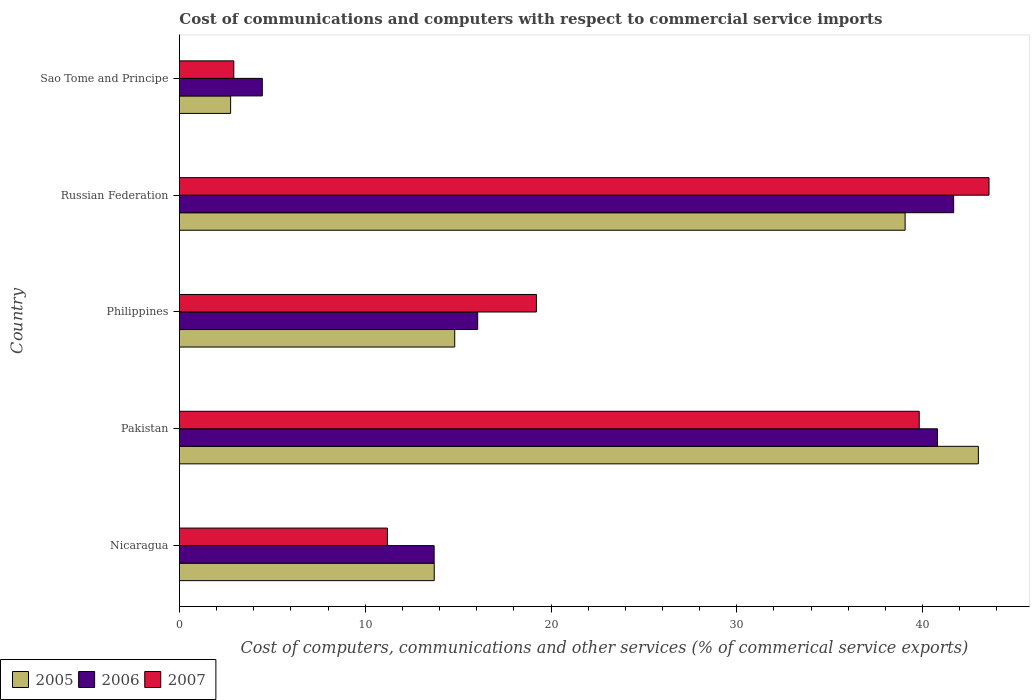How many different coloured bars are there?
Give a very brief answer. 3. Are the number of bars per tick equal to the number of legend labels?
Give a very brief answer. Yes. Are the number of bars on each tick of the Y-axis equal?
Give a very brief answer. Yes. How many bars are there on the 4th tick from the top?
Your response must be concise. 3. How many bars are there on the 5th tick from the bottom?
Offer a very short reply. 3. What is the label of the 4th group of bars from the top?
Ensure brevity in your answer.  Pakistan. What is the cost of communications and computers in 2007 in Philippines?
Provide a succinct answer. 19.22. Across all countries, what is the maximum cost of communications and computers in 2005?
Offer a terse response. 43. Across all countries, what is the minimum cost of communications and computers in 2007?
Offer a very short reply. 2.93. In which country was the cost of communications and computers in 2007 maximum?
Offer a very short reply. Russian Federation. In which country was the cost of communications and computers in 2005 minimum?
Ensure brevity in your answer.  Sao Tome and Principe. What is the total cost of communications and computers in 2005 in the graph?
Provide a succinct answer. 113.35. What is the difference between the cost of communications and computers in 2007 in Nicaragua and that in Philippines?
Provide a succinct answer. -8.02. What is the difference between the cost of communications and computers in 2006 in Russian Federation and the cost of communications and computers in 2005 in Philippines?
Provide a succinct answer. 26.85. What is the average cost of communications and computers in 2005 per country?
Give a very brief answer. 22.67. What is the difference between the cost of communications and computers in 2007 and cost of communications and computers in 2006 in Philippines?
Offer a very short reply. 3.16. In how many countries, is the cost of communications and computers in 2006 greater than 24 %?
Keep it short and to the point. 2. What is the ratio of the cost of communications and computers in 2005 in Pakistan to that in Russian Federation?
Ensure brevity in your answer.  1.1. What is the difference between the highest and the second highest cost of communications and computers in 2006?
Your response must be concise. 0.87. What is the difference between the highest and the lowest cost of communications and computers in 2006?
Your answer should be compact. 37.21. Is the sum of the cost of communications and computers in 2007 in Philippines and Russian Federation greater than the maximum cost of communications and computers in 2005 across all countries?
Your answer should be very brief. Yes. What does the 3rd bar from the top in Philippines represents?
Provide a short and direct response. 2005. How many bars are there?
Provide a succinct answer. 15. Are all the bars in the graph horizontal?
Provide a succinct answer. Yes. What is the difference between two consecutive major ticks on the X-axis?
Give a very brief answer. 10. Does the graph contain any zero values?
Offer a terse response. No. Does the graph contain grids?
Your answer should be compact. No. How many legend labels are there?
Your answer should be very brief. 3. What is the title of the graph?
Keep it short and to the point. Cost of communications and computers with respect to commercial service imports. Does "1964" appear as one of the legend labels in the graph?
Offer a terse response. No. What is the label or title of the X-axis?
Ensure brevity in your answer.  Cost of computers, communications and other services (% of commerical service exports). What is the Cost of computers, communications and other services (% of commerical service exports) in 2005 in Nicaragua?
Offer a terse response. 13.72. What is the Cost of computers, communications and other services (% of commerical service exports) of 2006 in Nicaragua?
Provide a short and direct response. 13.71. What is the Cost of computers, communications and other services (% of commerical service exports) of 2007 in Nicaragua?
Make the answer very short. 11.2. What is the Cost of computers, communications and other services (% of commerical service exports) of 2005 in Pakistan?
Keep it short and to the point. 43. What is the Cost of computers, communications and other services (% of commerical service exports) of 2006 in Pakistan?
Offer a very short reply. 40.8. What is the Cost of computers, communications and other services (% of commerical service exports) in 2007 in Pakistan?
Provide a succinct answer. 39.82. What is the Cost of computers, communications and other services (% of commerical service exports) in 2005 in Philippines?
Give a very brief answer. 14.82. What is the Cost of computers, communications and other services (% of commerical service exports) in 2006 in Philippines?
Provide a short and direct response. 16.05. What is the Cost of computers, communications and other services (% of commerical service exports) in 2007 in Philippines?
Give a very brief answer. 19.22. What is the Cost of computers, communications and other services (% of commerical service exports) of 2005 in Russian Federation?
Your response must be concise. 39.06. What is the Cost of computers, communications and other services (% of commerical service exports) of 2006 in Russian Federation?
Offer a very short reply. 41.67. What is the Cost of computers, communications and other services (% of commerical service exports) in 2007 in Russian Federation?
Give a very brief answer. 43.57. What is the Cost of computers, communications and other services (% of commerical service exports) in 2005 in Sao Tome and Principe?
Offer a very short reply. 2.76. What is the Cost of computers, communications and other services (% of commerical service exports) of 2006 in Sao Tome and Principe?
Offer a terse response. 4.46. What is the Cost of computers, communications and other services (% of commerical service exports) of 2007 in Sao Tome and Principe?
Make the answer very short. 2.93. Across all countries, what is the maximum Cost of computers, communications and other services (% of commerical service exports) of 2005?
Ensure brevity in your answer.  43. Across all countries, what is the maximum Cost of computers, communications and other services (% of commerical service exports) of 2006?
Ensure brevity in your answer.  41.67. Across all countries, what is the maximum Cost of computers, communications and other services (% of commerical service exports) in 2007?
Provide a succinct answer. 43.57. Across all countries, what is the minimum Cost of computers, communications and other services (% of commerical service exports) in 2005?
Your answer should be compact. 2.76. Across all countries, what is the minimum Cost of computers, communications and other services (% of commerical service exports) of 2006?
Your answer should be very brief. 4.46. Across all countries, what is the minimum Cost of computers, communications and other services (% of commerical service exports) of 2007?
Your response must be concise. 2.93. What is the total Cost of computers, communications and other services (% of commerical service exports) of 2005 in the graph?
Your answer should be compact. 113.35. What is the total Cost of computers, communications and other services (% of commerical service exports) of 2006 in the graph?
Provide a short and direct response. 116.7. What is the total Cost of computers, communications and other services (% of commerical service exports) in 2007 in the graph?
Offer a very short reply. 116.73. What is the difference between the Cost of computers, communications and other services (% of commerical service exports) of 2005 in Nicaragua and that in Pakistan?
Ensure brevity in your answer.  -29.29. What is the difference between the Cost of computers, communications and other services (% of commerical service exports) in 2006 in Nicaragua and that in Pakistan?
Ensure brevity in your answer.  -27.09. What is the difference between the Cost of computers, communications and other services (% of commerical service exports) in 2007 in Nicaragua and that in Pakistan?
Give a very brief answer. -28.62. What is the difference between the Cost of computers, communications and other services (% of commerical service exports) in 2005 in Nicaragua and that in Philippines?
Provide a short and direct response. -1.1. What is the difference between the Cost of computers, communications and other services (% of commerical service exports) in 2006 in Nicaragua and that in Philippines?
Offer a terse response. -2.34. What is the difference between the Cost of computers, communications and other services (% of commerical service exports) of 2007 in Nicaragua and that in Philippines?
Provide a short and direct response. -8.02. What is the difference between the Cost of computers, communications and other services (% of commerical service exports) of 2005 in Nicaragua and that in Russian Federation?
Provide a short and direct response. -25.34. What is the difference between the Cost of computers, communications and other services (% of commerical service exports) in 2006 in Nicaragua and that in Russian Federation?
Keep it short and to the point. -27.96. What is the difference between the Cost of computers, communications and other services (% of commerical service exports) in 2007 in Nicaragua and that in Russian Federation?
Offer a very short reply. -32.38. What is the difference between the Cost of computers, communications and other services (% of commerical service exports) in 2005 in Nicaragua and that in Sao Tome and Principe?
Offer a terse response. 10.96. What is the difference between the Cost of computers, communications and other services (% of commerical service exports) in 2006 in Nicaragua and that in Sao Tome and Principe?
Offer a very short reply. 9.25. What is the difference between the Cost of computers, communications and other services (% of commerical service exports) of 2007 in Nicaragua and that in Sao Tome and Principe?
Keep it short and to the point. 8.27. What is the difference between the Cost of computers, communications and other services (% of commerical service exports) of 2005 in Pakistan and that in Philippines?
Provide a short and direct response. 28.18. What is the difference between the Cost of computers, communications and other services (% of commerical service exports) in 2006 in Pakistan and that in Philippines?
Provide a short and direct response. 24.75. What is the difference between the Cost of computers, communications and other services (% of commerical service exports) of 2007 in Pakistan and that in Philippines?
Keep it short and to the point. 20.6. What is the difference between the Cost of computers, communications and other services (% of commerical service exports) in 2005 in Pakistan and that in Russian Federation?
Ensure brevity in your answer.  3.94. What is the difference between the Cost of computers, communications and other services (% of commerical service exports) in 2006 in Pakistan and that in Russian Federation?
Your answer should be very brief. -0.87. What is the difference between the Cost of computers, communications and other services (% of commerical service exports) of 2007 in Pakistan and that in Russian Federation?
Your response must be concise. -3.76. What is the difference between the Cost of computers, communications and other services (% of commerical service exports) of 2005 in Pakistan and that in Sao Tome and Principe?
Keep it short and to the point. 40.25. What is the difference between the Cost of computers, communications and other services (% of commerical service exports) of 2006 in Pakistan and that in Sao Tome and Principe?
Ensure brevity in your answer.  36.34. What is the difference between the Cost of computers, communications and other services (% of commerical service exports) in 2007 in Pakistan and that in Sao Tome and Principe?
Your answer should be compact. 36.89. What is the difference between the Cost of computers, communications and other services (% of commerical service exports) of 2005 in Philippines and that in Russian Federation?
Your response must be concise. -24.24. What is the difference between the Cost of computers, communications and other services (% of commerical service exports) of 2006 in Philippines and that in Russian Federation?
Your answer should be very brief. -25.62. What is the difference between the Cost of computers, communications and other services (% of commerical service exports) in 2007 in Philippines and that in Russian Federation?
Your response must be concise. -24.36. What is the difference between the Cost of computers, communications and other services (% of commerical service exports) of 2005 in Philippines and that in Sao Tome and Principe?
Provide a short and direct response. 12.06. What is the difference between the Cost of computers, communications and other services (% of commerical service exports) of 2006 in Philippines and that in Sao Tome and Principe?
Your answer should be very brief. 11.59. What is the difference between the Cost of computers, communications and other services (% of commerical service exports) in 2007 in Philippines and that in Sao Tome and Principe?
Offer a terse response. 16.29. What is the difference between the Cost of computers, communications and other services (% of commerical service exports) of 2005 in Russian Federation and that in Sao Tome and Principe?
Give a very brief answer. 36.3. What is the difference between the Cost of computers, communications and other services (% of commerical service exports) in 2006 in Russian Federation and that in Sao Tome and Principe?
Offer a very short reply. 37.21. What is the difference between the Cost of computers, communications and other services (% of commerical service exports) of 2007 in Russian Federation and that in Sao Tome and Principe?
Give a very brief answer. 40.65. What is the difference between the Cost of computers, communications and other services (% of commerical service exports) of 2005 in Nicaragua and the Cost of computers, communications and other services (% of commerical service exports) of 2006 in Pakistan?
Your answer should be very brief. -27.09. What is the difference between the Cost of computers, communications and other services (% of commerical service exports) of 2005 in Nicaragua and the Cost of computers, communications and other services (% of commerical service exports) of 2007 in Pakistan?
Your answer should be compact. -26.1. What is the difference between the Cost of computers, communications and other services (% of commerical service exports) in 2006 in Nicaragua and the Cost of computers, communications and other services (% of commerical service exports) in 2007 in Pakistan?
Offer a very short reply. -26.11. What is the difference between the Cost of computers, communications and other services (% of commerical service exports) of 2005 in Nicaragua and the Cost of computers, communications and other services (% of commerical service exports) of 2006 in Philippines?
Give a very brief answer. -2.34. What is the difference between the Cost of computers, communications and other services (% of commerical service exports) in 2005 in Nicaragua and the Cost of computers, communications and other services (% of commerical service exports) in 2007 in Philippines?
Offer a very short reply. -5.5. What is the difference between the Cost of computers, communications and other services (% of commerical service exports) in 2006 in Nicaragua and the Cost of computers, communications and other services (% of commerical service exports) in 2007 in Philippines?
Give a very brief answer. -5.51. What is the difference between the Cost of computers, communications and other services (% of commerical service exports) in 2005 in Nicaragua and the Cost of computers, communications and other services (% of commerical service exports) in 2006 in Russian Federation?
Your answer should be very brief. -27.96. What is the difference between the Cost of computers, communications and other services (% of commerical service exports) of 2005 in Nicaragua and the Cost of computers, communications and other services (% of commerical service exports) of 2007 in Russian Federation?
Offer a terse response. -29.86. What is the difference between the Cost of computers, communications and other services (% of commerical service exports) in 2006 in Nicaragua and the Cost of computers, communications and other services (% of commerical service exports) in 2007 in Russian Federation?
Make the answer very short. -29.86. What is the difference between the Cost of computers, communications and other services (% of commerical service exports) of 2005 in Nicaragua and the Cost of computers, communications and other services (% of commerical service exports) of 2006 in Sao Tome and Principe?
Make the answer very short. 9.25. What is the difference between the Cost of computers, communications and other services (% of commerical service exports) of 2005 in Nicaragua and the Cost of computers, communications and other services (% of commerical service exports) of 2007 in Sao Tome and Principe?
Ensure brevity in your answer.  10.79. What is the difference between the Cost of computers, communications and other services (% of commerical service exports) in 2006 in Nicaragua and the Cost of computers, communications and other services (% of commerical service exports) in 2007 in Sao Tome and Principe?
Offer a very short reply. 10.78. What is the difference between the Cost of computers, communications and other services (% of commerical service exports) in 2005 in Pakistan and the Cost of computers, communications and other services (% of commerical service exports) in 2006 in Philippines?
Make the answer very short. 26.95. What is the difference between the Cost of computers, communications and other services (% of commerical service exports) in 2005 in Pakistan and the Cost of computers, communications and other services (% of commerical service exports) in 2007 in Philippines?
Offer a very short reply. 23.79. What is the difference between the Cost of computers, communications and other services (% of commerical service exports) of 2006 in Pakistan and the Cost of computers, communications and other services (% of commerical service exports) of 2007 in Philippines?
Offer a very short reply. 21.58. What is the difference between the Cost of computers, communications and other services (% of commerical service exports) in 2005 in Pakistan and the Cost of computers, communications and other services (% of commerical service exports) in 2006 in Russian Federation?
Provide a short and direct response. 1.33. What is the difference between the Cost of computers, communications and other services (% of commerical service exports) in 2005 in Pakistan and the Cost of computers, communications and other services (% of commerical service exports) in 2007 in Russian Federation?
Provide a short and direct response. -0.57. What is the difference between the Cost of computers, communications and other services (% of commerical service exports) in 2006 in Pakistan and the Cost of computers, communications and other services (% of commerical service exports) in 2007 in Russian Federation?
Your answer should be compact. -2.77. What is the difference between the Cost of computers, communications and other services (% of commerical service exports) in 2005 in Pakistan and the Cost of computers, communications and other services (% of commerical service exports) in 2006 in Sao Tome and Principe?
Ensure brevity in your answer.  38.54. What is the difference between the Cost of computers, communications and other services (% of commerical service exports) of 2005 in Pakistan and the Cost of computers, communications and other services (% of commerical service exports) of 2007 in Sao Tome and Principe?
Your answer should be very brief. 40.07. What is the difference between the Cost of computers, communications and other services (% of commerical service exports) of 2006 in Pakistan and the Cost of computers, communications and other services (% of commerical service exports) of 2007 in Sao Tome and Principe?
Offer a very short reply. 37.87. What is the difference between the Cost of computers, communications and other services (% of commerical service exports) in 2005 in Philippines and the Cost of computers, communications and other services (% of commerical service exports) in 2006 in Russian Federation?
Keep it short and to the point. -26.85. What is the difference between the Cost of computers, communications and other services (% of commerical service exports) in 2005 in Philippines and the Cost of computers, communications and other services (% of commerical service exports) in 2007 in Russian Federation?
Give a very brief answer. -28.76. What is the difference between the Cost of computers, communications and other services (% of commerical service exports) in 2006 in Philippines and the Cost of computers, communications and other services (% of commerical service exports) in 2007 in Russian Federation?
Provide a short and direct response. -27.52. What is the difference between the Cost of computers, communications and other services (% of commerical service exports) of 2005 in Philippines and the Cost of computers, communications and other services (% of commerical service exports) of 2006 in Sao Tome and Principe?
Provide a short and direct response. 10.36. What is the difference between the Cost of computers, communications and other services (% of commerical service exports) in 2005 in Philippines and the Cost of computers, communications and other services (% of commerical service exports) in 2007 in Sao Tome and Principe?
Offer a very short reply. 11.89. What is the difference between the Cost of computers, communications and other services (% of commerical service exports) of 2006 in Philippines and the Cost of computers, communications and other services (% of commerical service exports) of 2007 in Sao Tome and Principe?
Offer a terse response. 13.13. What is the difference between the Cost of computers, communications and other services (% of commerical service exports) of 2005 in Russian Federation and the Cost of computers, communications and other services (% of commerical service exports) of 2006 in Sao Tome and Principe?
Your answer should be compact. 34.6. What is the difference between the Cost of computers, communications and other services (% of commerical service exports) in 2005 in Russian Federation and the Cost of computers, communications and other services (% of commerical service exports) in 2007 in Sao Tome and Principe?
Your answer should be compact. 36.13. What is the difference between the Cost of computers, communications and other services (% of commerical service exports) of 2006 in Russian Federation and the Cost of computers, communications and other services (% of commerical service exports) of 2007 in Sao Tome and Principe?
Your answer should be very brief. 38.74. What is the average Cost of computers, communications and other services (% of commerical service exports) of 2005 per country?
Give a very brief answer. 22.67. What is the average Cost of computers, communications and other services (% of commerical service exports) in 2006 per country?
Your response must be concise. 23.34. What is the average Cost of computers, communications and other services (% of commerical service exports) in 2007 per country?
Keep it short and to the point. 23.35. What is the difference between the Cost of computers, communications and other services (% of commerical service exports) of 2005 and Cost of computers, communications and other services (% of commerical service exports) of 2006 in Nicaragua?
Offer a very short reply. 0.01. What is the difference between the Cost of computers, communications and other services (% of commerical service exports) of 2005 and Cost of computers, communications and other services (% of commerical service exports) of 2007 in Nicaragua?
Your answer should be very brief. 2.52. What is the difference between the Cost of computers, communications and other services (% of commerical service exports) in 2006 and Cost of computers, communications and other services (% of commerical service exports) in 2007 in Nicaragua?
Your response must be concise. 2.52. What is the difference between the Cost of computers, communications and other services (% of commerical service exports) of 2005 and Cost of computers, communications and other services (% of commerical service exports) of 2006 in Pakistan?
Your answer should be very brief. 2.2. What is the difference between the Cost of computers, communications and other services (% of commerical service exports) of 2005 and Cost of computers, communications and other services (% of commerical service exports) of 2007 in Pakistan?
Your response must be concise. 3.18. What is the difference between the Cost of computers, communications and other services (% of commerical service exports) of 2006 and Cost of computers, communications and other services (% of commerical service exports) of 2007 in Pakistan?
Your answer should be very brief. 0.98. What is the difference between the Cost of computers, communications and other services (% of commerical service exports) in 2005 and Cost of computers, communications and other services (% of commerical service exports) in 2006 in Philippines?
Ensure brevity in your answer.  -1.24. What is the difference between the Cost of computers, communications and other services (% of commerical service exports) in 2005 and Cost of computers, communications and other services (% of commerical service exports) in 2007 in Philippines?
Your answer should be very brief. -4.4. What is the difference between the Cost of computers, communications and other services (% of commerical service exports) in 2006 and Cost of computers, communications and other services (% of commerical service exports) in 2007 in Philippines?
Offer a terse response. -3.16. What is the difference between the Cost of computers, communications and other services (% of commerical service exports) of 2005 and Cost of computers, communications and other services (% of commerical service exports) of 2006 in Russian Federation?
Your answer should be very brief. -2.61. What is the difference between the Cost of computers, communications and other services (% of commerical service exports) of 2005 and Cost of computers, communications and other services (% of commerical service exports) of 2007 in Russian Federation?
Offer a very short reply. -4.52. What is the difference between the Cost of computers, communications and other services (% of commerical service exports) of 2006 and Cost of computers, communications and other services (% of commerical service exports) of 2007 in Russian Federation?
Make the answer very short. -1.9. What is the difference between the Cost of computers, communications and other services (% of commerical service exports) in 2005 and Cost of computers, communications and other services (% of commerical service exports) in 2006 in Sao Tome and Principe?
Offer a very short reply. -1.71. What is the difference between the Cost of computers, communications and other services (% of commerical service exports) in 2005 and Cost of computers, communications and other services (% of commerical service exports) in 2007 in Sao Tome and Principe?
Provide a short and direct response. -0.17. What is the difference between the Cost of computers, communications and other services (% of commerical service exports) in 2006 and Cost of computers, communications and other services (% of commerical service exports) in 2007 in Sao Tome and Principe?
Make the answer very short. 1.53. What is the ratio of the Cost of computers, communications and other services (% of commerical service exports) of 2005 in Nicaragua to that in Pakistan?
Make the answer very short. 0.32. What is the ratio of the Cost of computers, communications and other services (% of commerical service exports) of 2006 in Nicaragua to that in Pakistan?
Keep it short and to the point. 0.34. What is the ratio of the Cost of computers, communications and other services (% of commerical service exports) of 2007 in Nicaragua to that in Pakistan?
Your response must be concise. 0.28. What is the ratio of the Cost of computers, communications and other services (% of commerical service exports) of 2005 in Nicaragua to that in Philippines?
Keep it short and to the point. 0.93. What is the ratio of the Cost of computers, communications and other services (% of commerical service exports) in 2006 in Nicaragua to that in Philippines?
Make the answer very short. 0.85. What is the ratio of the Cost of computers, communications and other services (% of commerical service exports) of 2007 in Nicaragua to that in Philippines?
Make the answer very short. 0.58. What is the ratio of the Cost of computers, communications and other services (% of commerical service exports) of 2005 in Nicaragua to that in Russian Federation?
Give a very brief answer. 0.35. What is the ratio of the Cost of computers, communications and other services (% of commerical service exports) in 2006 in Nicaragua to that in Russian Federation?
Give a very brief answer. 0.33. What is the ratio of the Cost of computers, communications and other services (% of commerical service exports) of 2007 in Nicaragua to that in Russian Federation?
Provide a short and direct response. 0.26. What is the ratio of the Cost of computers, communications and other services (% of commerical service exports) in 2005 in Nicaragua to that in Sao Tome and Principe?
Give a very brief answer. 4.98. What is the ratio of the Cost of computers, communications and other services (% of commerical service exports) in 2006 in Nicaragua to that in Sao Tome and Principe?
Give a very brief answer. 3.07. What is the ratio of the Cost of computers, communications and other services (% of commerical service exports) of 2007 in Nicaragua to that in Sao Tome and Principe?
Make the answer very short. 3.82. What is the ratio of the Cost of computers, communications and other services (% of commerical service exports) in 2005 in Pakistan to that in Philippines?
Your response must be concise. 2.9. What is the ratio of the Cost of computers, communications and other services (% of commerical service exports) of 2006 in Pakistan to that in Philippines?
Offer a very short reply. 2.54. What is the ratio of the Cost of computers, communications and other services (% of commerical service exports) in 2007 in Pakistan to that in Philippines?
Provide a short and direct response. 2.07. What is the ratio of the Cost of computers, communications and other services (% of commerical service exports) of 2005 in Pakistan to that in Russian Federation?
Provide a succinct answer. 1.1. What is the ratio of the Cost of computers, communications and other services (% of commerical service exports) in 2006 in Pakistan to that in Russian Federation?
Keep it short and to the point. 0.98. What is the ratio of the Cost of computers, communications and other services (% of commerical service exports) of 2007 in Pakistan to that in Russian Federation?
Provide a succinct answer. 0.91. What is the ratio of the Cost of computers, communications and other services (% of commerical service exports) in 2005 in Pakistan to that in Sao Tome and Principe?
Provide a short and direct response. 15.61. What is the ratio of the Cost of computers, communications and other services (% of commerical service exports) of 2006 in Pakistan to that in Sao Tome and Principe?
Your answer should be very brief. 9.15. What is the ratio of the Cost of computers, communications and other services (% of commerical service exports) of 2005 in Philippines to that in Russian Federation?
Your response must be concise. 0.38. What is the ratio of the Cost of computers, communications and other services (% of commerical service exports) of 2006 in Philippines to that in Russian Federation?
Your response must be concise. 0.39. What is the ratio of the Cost of computers, communications and other services (% of commerical service exports) of 2007 in Philippines to that in Russian Federation?
Keep it short and to the point. 0.44. What is the ratio of the Cost of computers, communications and other services (% of commerical service exports) in 2005 in Philippines to that in Sao Tome and Principe?
Make the answer very short. 5.38. What is the ratio of the Cost of computers, communications and other services (% of commerical service exports) of 2006 in Philippines to that in Sao Tome and Principe?
Ensure brevity in your answer.  3.6. What is the ratio of the Cost of computers, communications and other services (% of commerical service exports) of 2007 in Philippines to that in Sao Tome and Principe?
Keep it short and to the point. 6.56. What is the ratio of the Cost of computers, communications and other services (% of commerical service exports) in 2005 in Russian Federation to that in Sao Tome and Principe?
Ensure brevity in your answer.  14.18. What is the ratio of the Cost of computers, communications and other services (% of commerical service exports) in 2006 in Russian Federation to that in Sao Tome and Principe?
Your answer should be compact. 9.34. What is the ratio of the Cost of computers, communications and other services (% of commerical service exports) of 2007 in Russian Federation to that in Sao Tome and Principe?
Ensure brevity in your answer.  14.88. What is the difference between the highest and the second highest Cost of computers, communications and other services (% of commerical service exports) in 2005?
Ensure brevity in your answer.  3.94. What is the difference between the highest and the second highest Cost of computers, communications and other services (% of commerical service exports) of 2006?
Your answer should be compact. 0.87. What is the difference between the highest and the second highest Cost of computers, communications and other services (% of commerical service exports) in 2007?
Your answer should be compact. 3.76. What is the difference between the highest and the lowest Cost of computers, communications and other services (% of commerical service exports) in 2005?
Offer a very short reply. 40.25. What is the difference between the highest and the lowest Cost of computers, communications and other services (% of commerical service exports) of 2006?
Provide a short and direct response. 37.21. What is the difference between the highest and the lowest Cost of computers, communications and other services (% of commerical service exports) in 2007?
Offer a terse response. 40.65. 